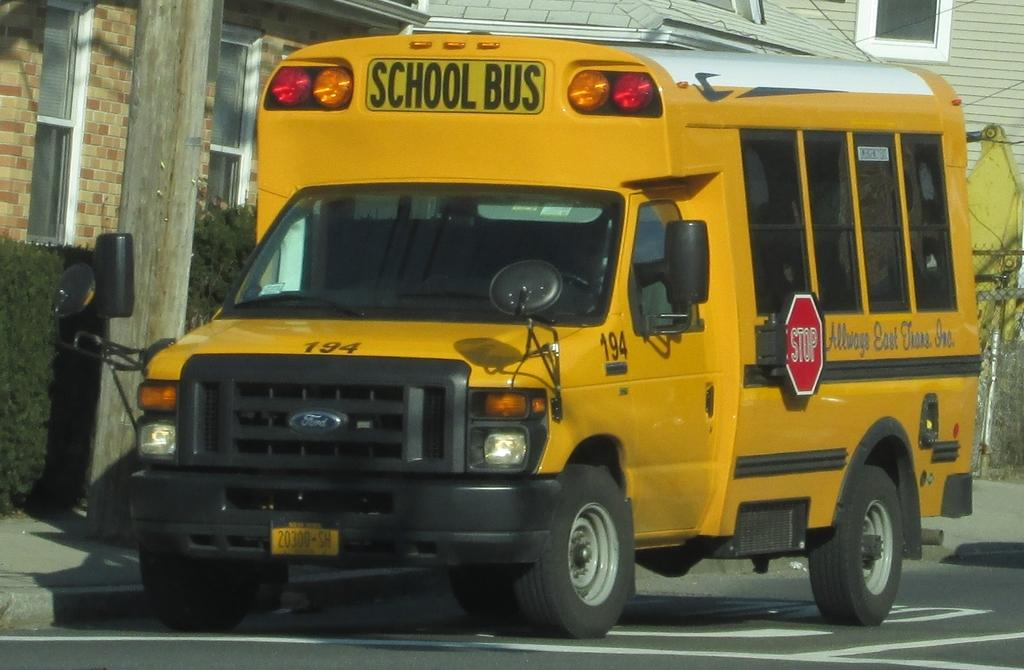What is the main subject of the image? There is a school bus in the image. What can be seen beneath the school bus? The ground is visible in the image. What is located on the left side of the image? There is a pole on the left side of the image. What type of vegetation is present in the image? There are plants in the image. What type of structures are visible in the image? There are walls with windows in the image. What type of barrier is present in the image? There is a fence in the image. What type of square is visible on the roof of the school bus? There is no square visible on the roof of the school bus in the image. Can you see a giraffe walking near the school bus? There is no giraffe present in the image; it features a school bus and other elements related to a school or transportation setting. 